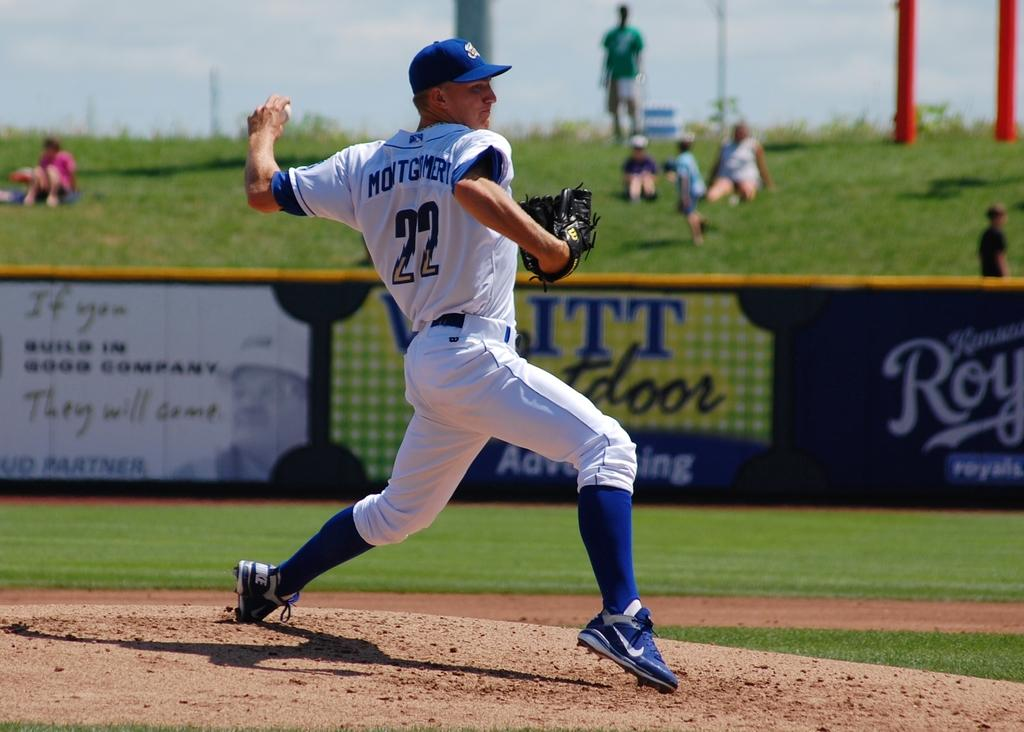<image>
Create a compact narrative representing the image presented. A pitcher throws the ball as a sign in the background proclaims they will come. 